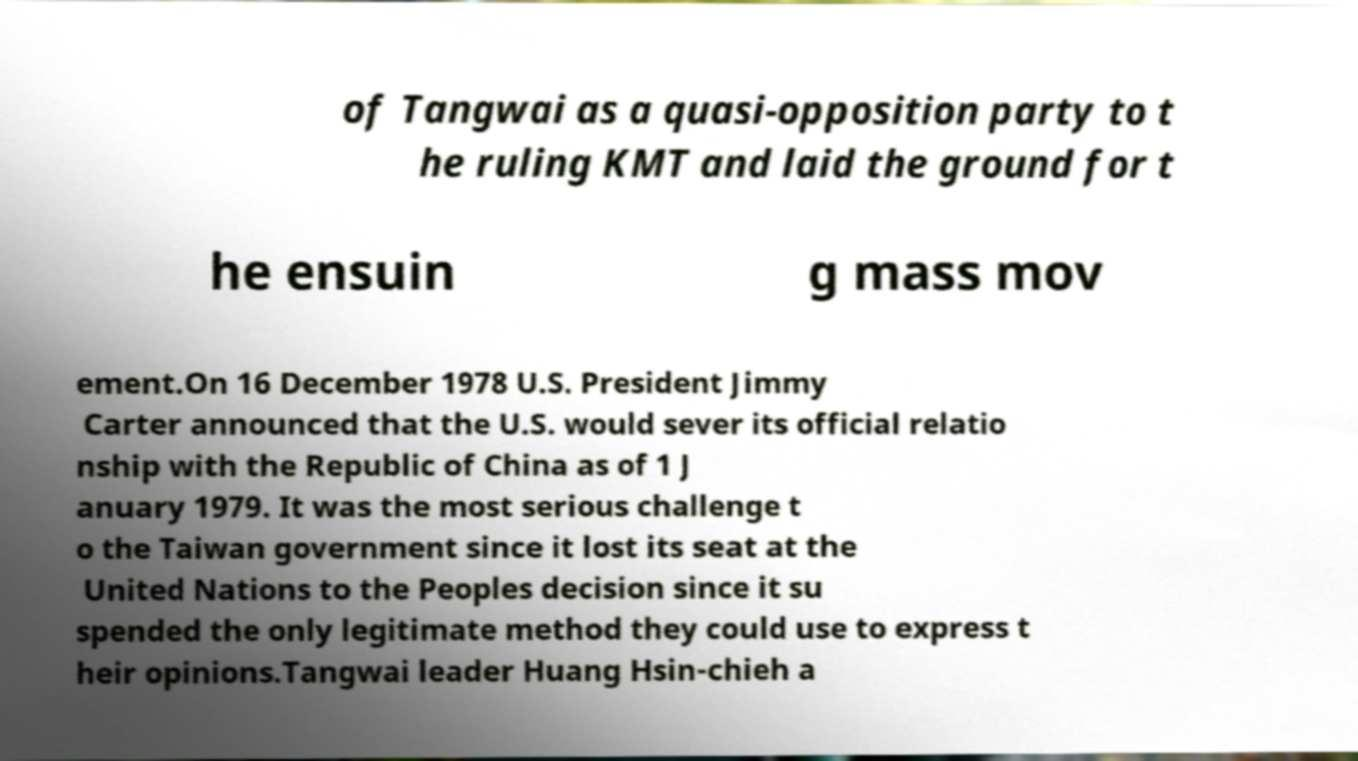Could you assist in decoding the text presented in this image and type it out clearly? of Tangwai as a quasi-opposition party to t he ruling KMT and laid the ground for t he ensuin g mass mov ement.On 16 December 1978 U.S. President Jimmy Carter announced that the U.S. would sever its official relatio nship with the Republic of China as of 1 J anuary 1979. It was the most serious challenge t o the Taiwan government since it lost its seat at the United Nations to the Peoples decision since it su spended the only legitimate method they could use to express t heir opinions.Tangwai leader Huang Hsin-chieh a 